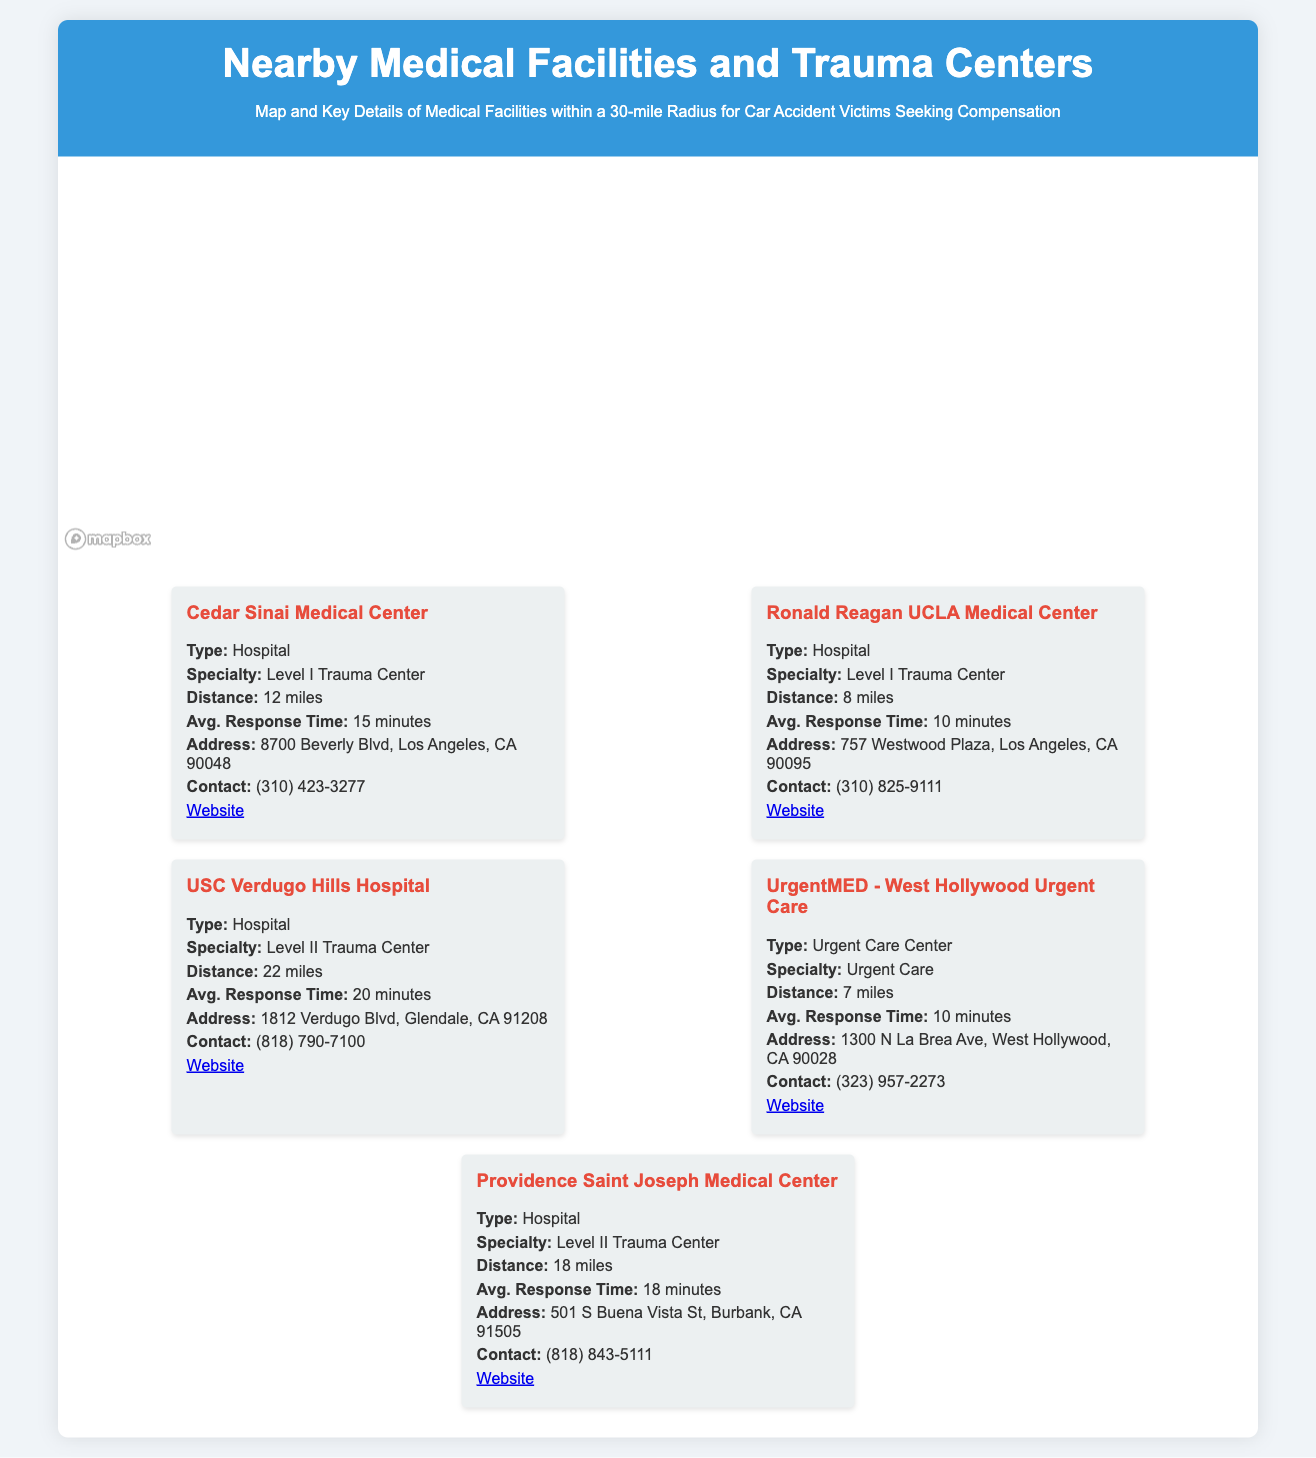What is the distance to Cedar Sinai Medical Center? Cedar Sinai Medical Center is located 12 miles away, as indicated in the document.
Answer: 12 miles What type of facility is Ronald Reagan UCLA Medical Center? The document specifies that Ronald Reagan UCLA Medical Center is a Hospital.
Answer: Hospital Which facility has the longest average response time? Comparing the response times listed, USC Verdugo Hills Hospital has the longest average response time of 20 minutes.
Answer: 20 minutes How many trauma centers are listed in the document? The document identifies 5 facilities, out of which 3 are trauma centers (Level I and Level II).
Answer: 3 What is the average response time for UrgentMED - West Hollywood Urgent Care? The document states that UrgentMED has an average response time of 10 minutes.
Answer: 10 minutes Which facility is located closest to the map's center? The Ronald Reagan UCLA Medical Center is closest to the map's center at 8 miles away.
Answer: 8 miles What is the specialty of Providence Saint Joseph Medical Center? Providence Saint Joseph Medical Center specializes as a Level II Trauma Center, as indicated in the document.
Answer: Level II Trauma Center Which two facilities have the same average response time? Both Ronald Reagan UCLA Medical Center and UrgentMED have the same average response time of 10 minutes.
Answer: 10 minutes What color represents hospitals in the legend? The legend indicates that the color red represents hospitals.
Answer: Red 